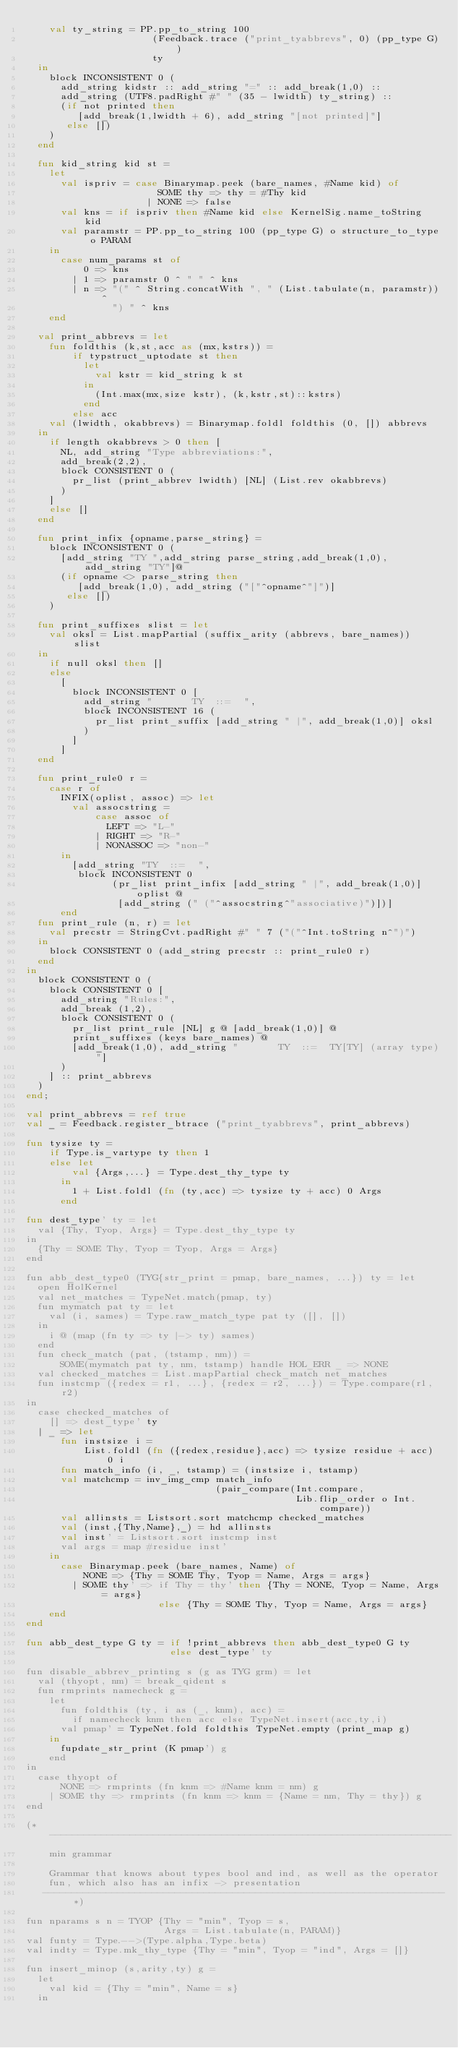Convert code to text. <code><loc_0><loc_0><loc_500><loc_500><_SML_>    val ty_string = PP.pp_to_string 100
                      (Feedback.trace ("print_tyabbrevs", 0) (pp_type G))
                      ty
  in
    block INCONSISTENT 0 (
      add_string kidstr :: add_string "=" :: add_break(1,0) ::
      add_string (UTF8.padRight #" " (35 - lwidth) ty_string) ::
      (if not printed then
         [add_break(1,lwidth + 6), add_string "[not printed]"]
       else [])
    )
  end

  fun kid_string kid st =
    let
      val ispriv = case Binarymap.peek (bare_names, #Name kid) of
                       SOME thy => thy = #Thy kid
                     | NONE => false
      val kns = if ispriv then #Name kid else KernelSig.name_toString kid
      val paramstr = PP.pp_to_string 100 (pp_type G) o structure_to_type o PARAM
    in
      case num_params st of
          0 => kns
        | 1 => paramstr 0 ^ " " ^ kns
        | n => "(" ^ String.concatWith ", " (List.tabulate(n, paramstr)) ^
               ") " ^ kns
    end

  val print_abbrevs = let
    fun foldthis (k,st,acc as (mx,kstrs)) =
        if typstruct_uptodate st then
          let
            val kstr = kid_string k st
          in
            (Int.max(mx,size kstr), (k,kstr,st)::kstrs)
          end
        else acc
    val (lwidth, okabbrevs) = Binarymap.foldl foldthis (0, []) abbrevs
  in
    if length okabbrevs > 0 then [
      NL, add_string "Type abbreviations:",
      add_break(2,2),
      block CONSISTENT 0 (
        pr_list (print_abbrev lwidth) [NL] (List.rev okabbrevs)
      )
    ]
    else []
  end

  fun print_infix {opname,parse_string} =
    block INCONSISTENT 0 (
      [add_string "TY ",add_string parse_string,add_break(1,0),add_string "TY"]@
      (if opname <> parse_string then
         [add_break(1,0), add_string ("["^opname^"]")]
       else [])
    )

  fun print_suffixes slist = let
    val oksl = List.mapPartial (suffix_arity (abbrevs, bare_names)) slist
  in
    if null oksl then []
    else
      [
        block INCONSISTENT 0 [
          add_string "       TY  ::=  ",
          block INCONSISTENT 16 (
            pr_list print_suffix [add_string " |", add_break(1,0)] oksl
          )
        ]
      ]
  end

  fun print_rule0 r =
    case r of
      INFIX(oplist, assoc) => let
        val assocstring =
            case assoc of
              LEFT => "L-"
            | RIGHT => "R-"
            | NONASSOC => "non-"
      in
        [add_string "TY  ::=  ",
         block INCONSISTENT 0
               (pr_list print_infix [add_string " |", add_break(1,0)] oplist @
                [add_string (" ("^assocstring^"associative)")])]
      end
  fun print_rule (n, r) = let
    val precstr = StringCvt.padRight #" " 7 ("("^Int.toString n^")")
  in
    block CONSISTENT 0 (add_string precstr :: print_rule0 r)
  end
in
  block CONSISTENT 0 (
    block CONSISTENT 0 [
      add_string "Rules:",
      add_break (1,2),
      block CONSISTENT 0 (
        pr_list print_rule [NL] g @ [add_break(1,0)] @
        print_suffixes (keys bare_names) @
        [add_break(1,0), add_string "       TY  ::=  TY[TY] (array type)"]
      )
    ] :: print_abbrevs
  )
end;

val print_abbrevs = ref true
val _ = Feedback.register_btrace ("print_tyabbrevs", print_abbrevs)

fun tysize ty =
    if Type.is_vartype ty then 1
    else let
        val {Args,...} = Type.dest_thy_type ty
      in
        1 + List.foldl (fn (ty,acc) => tysize ty + acc) 0 Args
      end

fun dest_type' ty = let
  val {Thy, Tyop, Args} = Type.dest_thy_type ty
in
  {Thy = SOME Thy, Tyop = Tyop, Args = Args}
end

fun abb_dest_type0 (TYG{str_print = pmap, bare_names, ...}) ty = let
  open HolKernel
  val net_matches = TypeNet.match(pmap, ty)
  fun mymatch pat ty = let
    val (i, sames) = Type.raw_match_type pat ty ([], [])
  in
    i @ (map (fn ty => ty |-> ty) sames)
  end
  fun check_match (pat, (tstamp, nm)) =
      SOME(mymatch pat ty, nm, tstamp) handle HOL_ERR _ => NONE
  val checked_matches = List.mapPartial check_match net_matches
  fun instcmp ({redex = r1, ...}, {redex = r2, ...}) = Type.compare(r1, r2)
in
  case checked_matches of
    [] => dest_type' ty
  | _ => let
      fun instsize i =
          List.foldl (fn ({redex,residue},acc) => tysize residue + acc) 0 i
      fun match_info (i, _, tstamp) = (instsize i, tstamp)
      val matchcmp = inv_img_cmp match_info
                                 (pair_compare(Int.compare,
                                               Lib.flip_order o Int.compare))
      val allinsts = Listsort.sort matchcmp checked_matches
      val (inst,{Thy,Name},_) = hd allinsts
      val inst' = Listsort.sort instcmp inst
      val args = map #residue inst'
    in
      case Binarymap.peek (bare_names, Name) of
          NONE => {Thy = SOME Thy, Tyop = Name, Args = args}
        | SOME thy' => if Thy = thy' then {Thy = NONE, Tyop = Name, Args = args}
                       else {Thy = SOME Thy, Tyop = Name, Args = args}
    end
end

fun abb_dest_type G ty = if !print_abbrevs then abb_dest_type0 G ty
                         else dest_type' ty

fun disable_abbrev_printing s (g as TYG grm) = let
  val (thyopt, nm) = break_qident s
  fun rmprints namecheck g =
    let
      fun foldthis (ty, i as (_, knm), acc) =
        if namecheck knm then acc else TypeNet.insert(acc,ty,i)
      val pmap' = TypeNet.fold foldthis TypeNet.empty (print_map g)
    in
      fupdate_str_print (K pmap') g
    end
in
  case thyopt of
      NONE => rmprints (fn knm => #Name knm = nm) g
    | SOME thy => rmprints (fn knm => knm = {Name = nm, Thy = thy}) g
end

(* ----------------------------------------------------------------------
    min grammar

    Grammar that knows about types bool and ind, as well as the operator
    fun, which also has an infix -> presentation
   ---------------------------------------------------------------------- *)

fun nparams s n = TYOP {Thy = "min", Tyop = s,
                        Args = List.tabulate(n, PARAM)}
val funty = Type.-->(Type.alpha,Type.beta)
val indty = Type.mk_thy_type {Thy = "min", Tyop = "ind", Args = []}

fun insert_minop (s,arity,ty) g =
  let
    val kid = {Thy = "min", Name = s}
  in</code> 